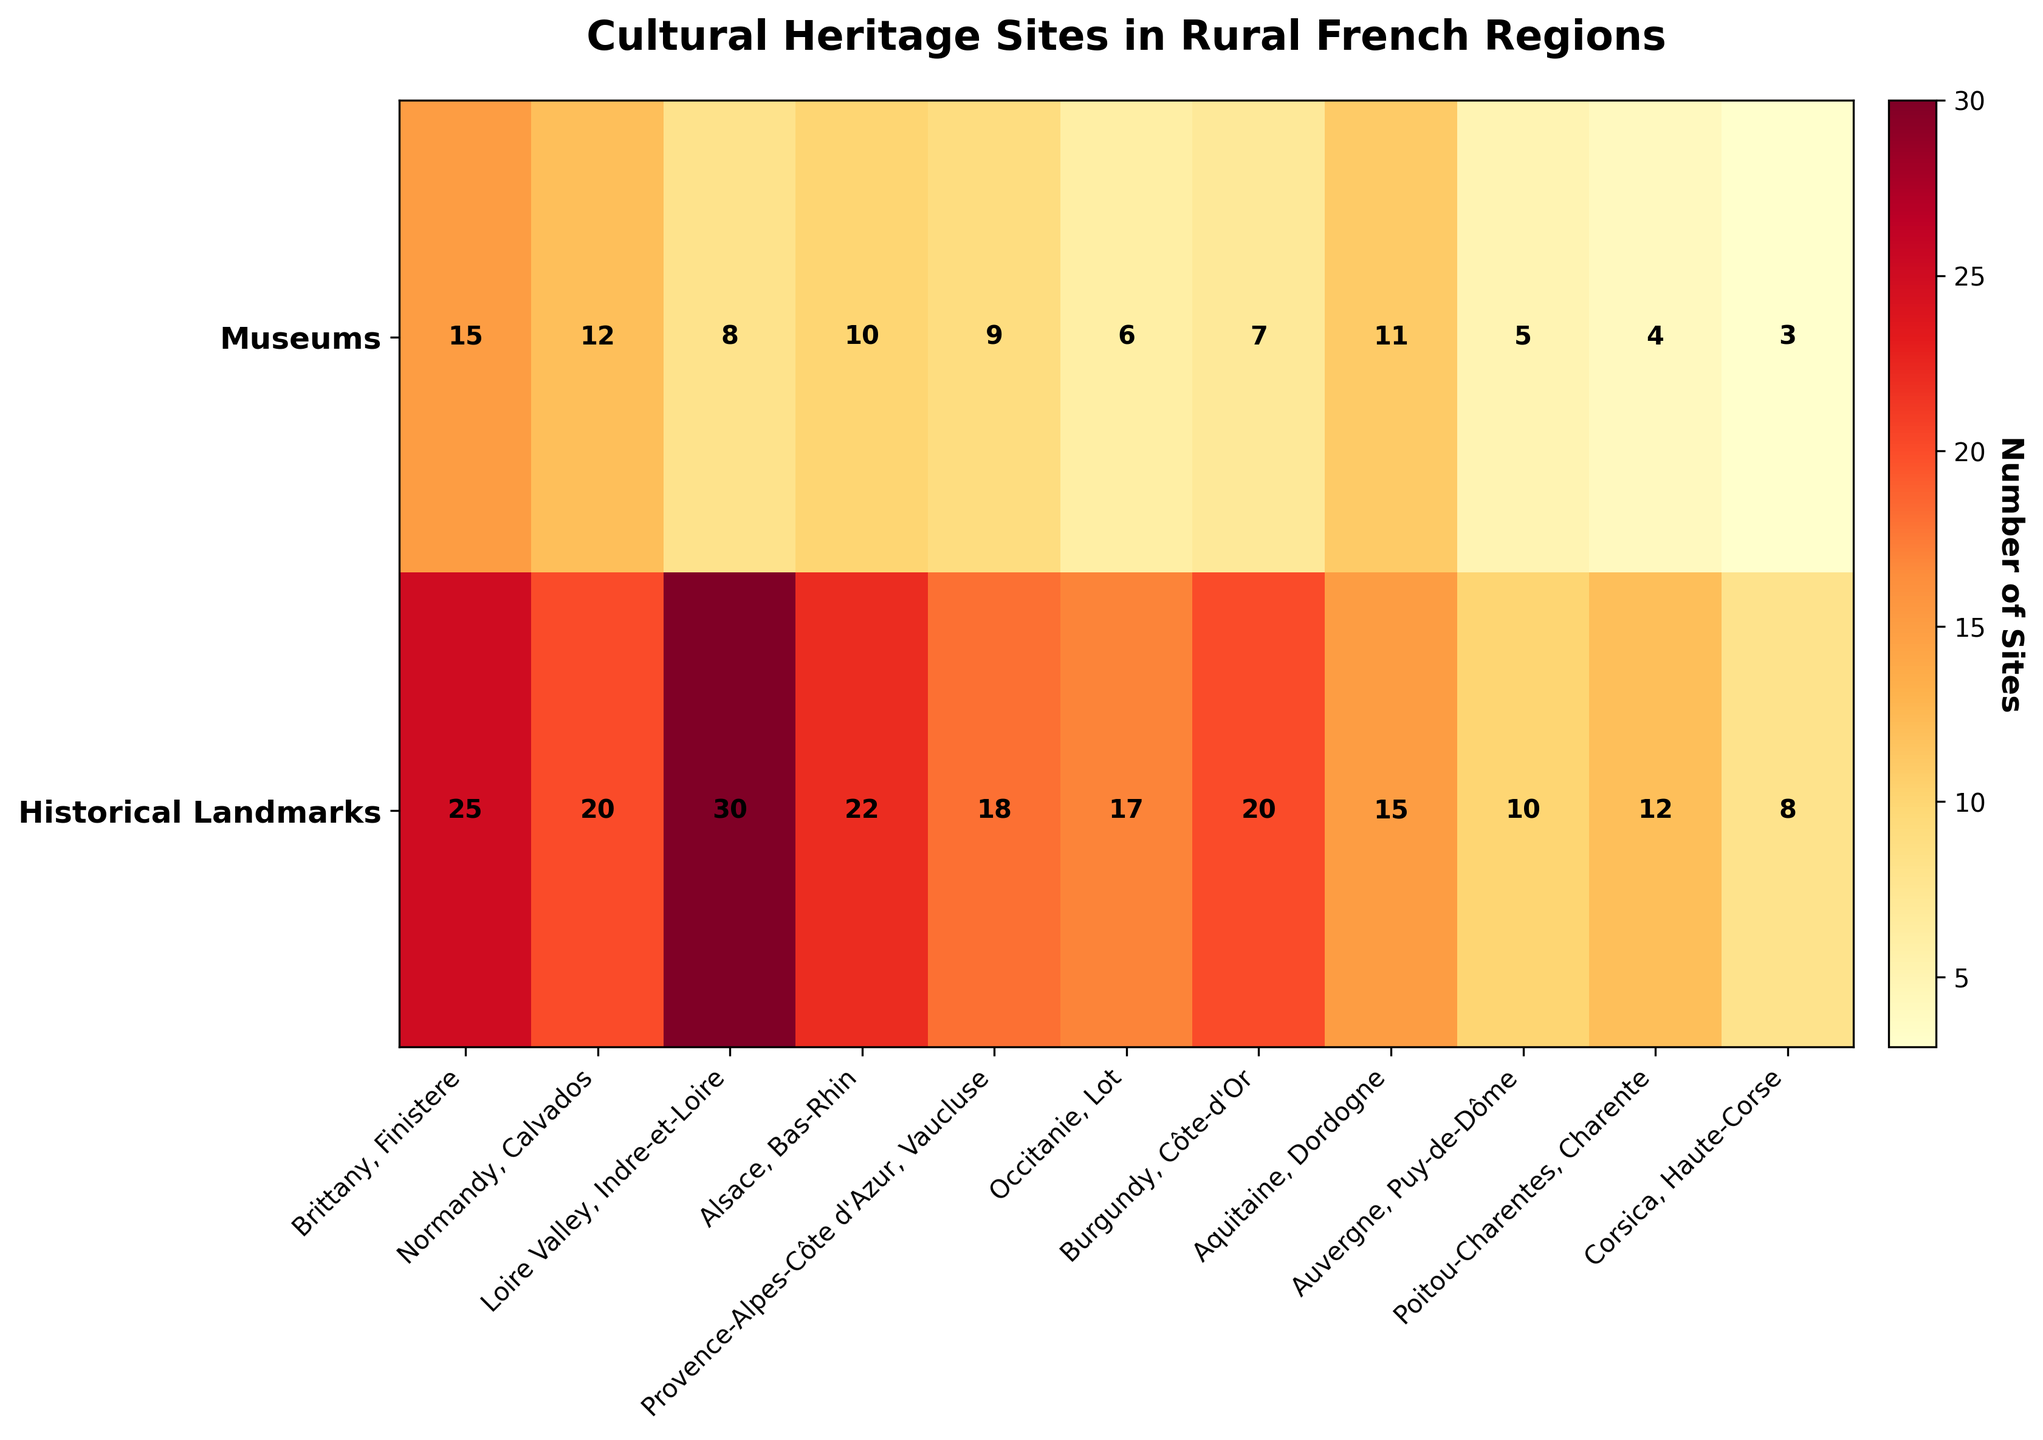What are the units on the color bar in the heatmap? The color bar represents the number of cultural heritage sites, with its units being the count of either museums or historical landmarks.
Answer: Count How many museums are there in the Dordogne subregion of Aquitaine? The heatmap shows values for each region and subregion; it's indicated by a marked value in the 'Museums' row corresponding to 'Aquitaine, Dordogne'. The number is 11.
Answer: 11 Which subregion in the figure has the highest number of historical landmarks? Look through the 'Historical Landmarks' row and identify the highest value, which is 30 in the figure, corresponding to 'Loire Valley, Indre-et-Loire'.
Answer: Loire Valley, Indre-et-Loire What’s the sum of museums in the Lot and Charente subregions? The number of museums for Lot is 6 and for Charente is 4. Summing these values gives 6 + 4 = 10.
Answer: 10 Which subregions have more museums than historical landmarks? Compare the two values (museums vs. historical landmarks) for each subregion: no subregion in the provided data has more museums than historical landmarks.
Answer: None What is the difference between the number of historical landmarks in Calvados and the number of museums in Bas-Rhin? Calvados has 20 historical landmarks, and Bas-Rhin has 10 museums. The difference is 20 - 10 = 10.
Answer: 10 Of all the subregions presented, which one has the highest total number of cultural heritage sites (museums + historical landmarks)? Sum the number of museums and historical landmarks for each subregion and compare them. Indre-et-Loire (Loire Valley) has the highest total with 8 + 30 = 38 sites.
Answer: Loire Valley, Indre-et-Loire In which subregions does the number of historical landmarks equal the number of museums multiplied by two? Multiply the number of museums by 2 for each subregion and check if it equals the number of historical landmarks: none of the subregions precisely fit this criterion.
Answer: None What’s the average number of museums across all subregions? Sum the museums in each subregion: 15 + 12 + 8 + 10 + 9 + 6 + 7 + 11 + 5 + 4 + 3 = 90. Divide by the number of subregions (11): 90 / 11 ≈ 8.18.
Answer: 8.18 